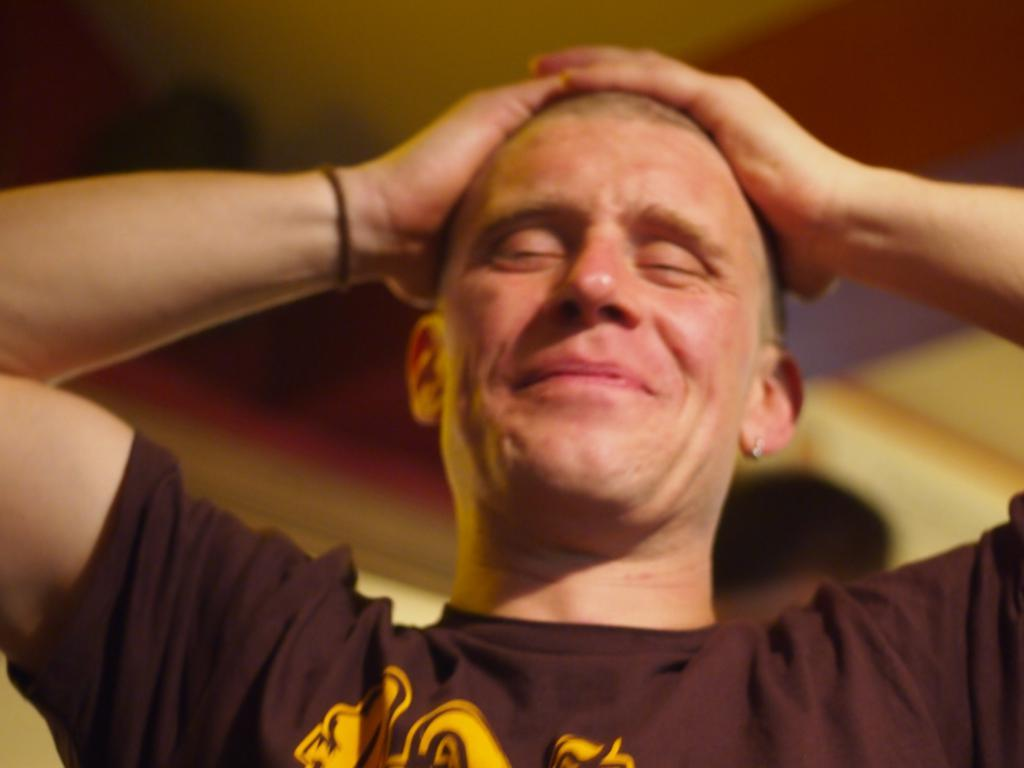Who is the main subject in the image? There is a man in the image. What is the man wearing? The man is wearing a t-shirt. Can you describe the background of the image? The background of the image is blurry. Are there any other people visible in the image? Yes, there is a person visible in the background of the image. What flavor of rose can be seen in the image? There are no roses present in the image, so it is not possible to determine the flavor of any rose. 